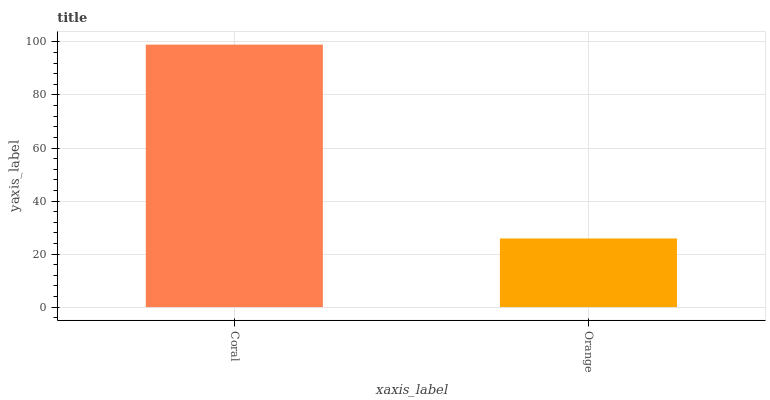Is Orange the minimum?
Answer yes or no. Yes. Is Coral the maximum?
Answer yes or no. Yes. Is Orange the maximum?
Answer yes or no. No. Is Coral greater than Orange?
Answer yes or no. Yes. Is Orange less than Coral?
Answer yes or no. Yes. Is Orange greater than Coral?
Answer yes or no. No. Is Coral less than Orange?
Answer yes or no. No. Is Coral the high median?
Answer yes or no. Yes. Is Orange the low median?
Answer yes or no. Yes. Is Orange the high median?
Answer yes or no. No. Is Coral the low median?
Answer yes or no. No. 